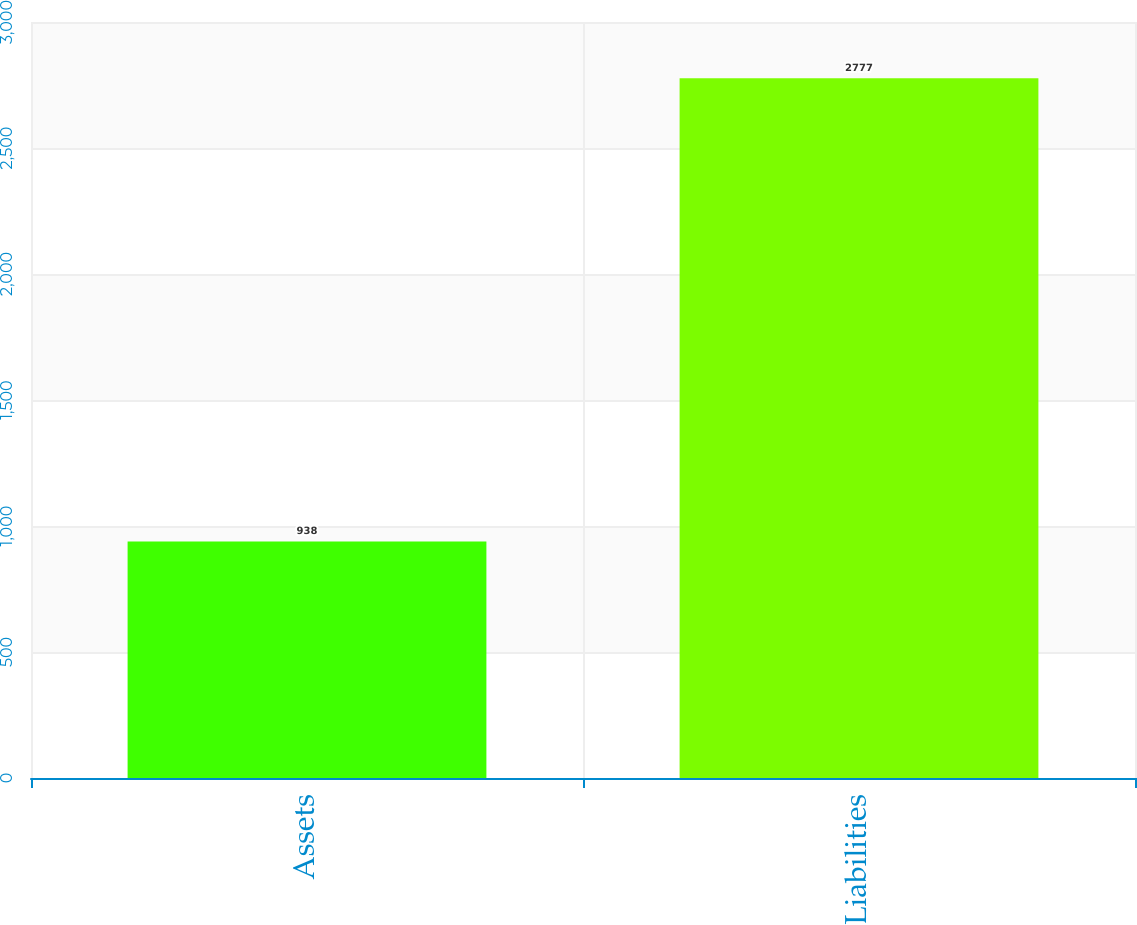Convert chart. <chart><loc_0><loc_0><loc_500><loc_500><bar_chart><fcel>Assets<fcel>Liabilities<nl><fcel>938<fcel>2777<nl></chart> 